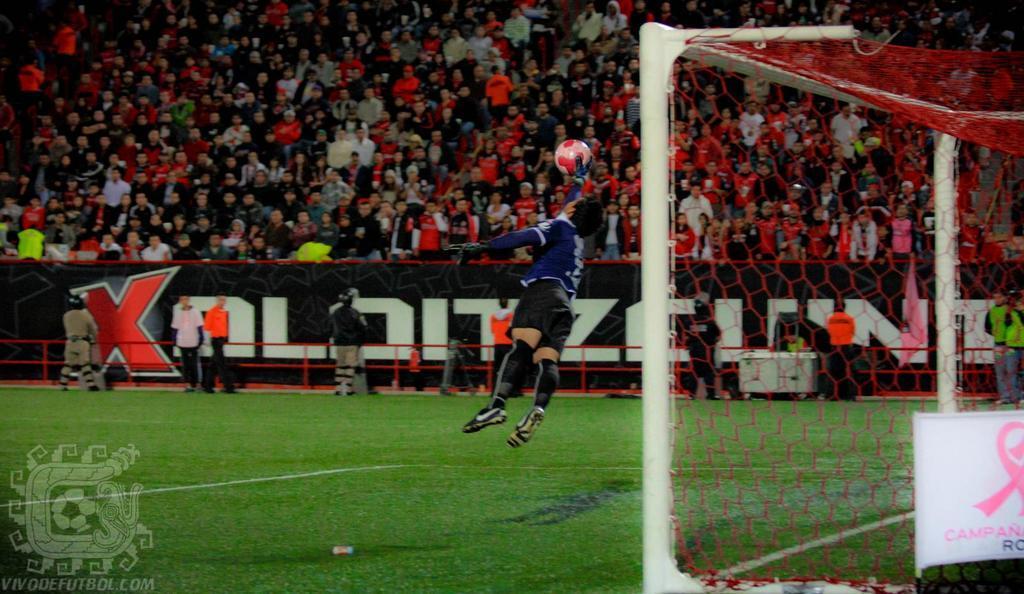Can you describe this image briefly? In this picture there are group of people standing behind the board and there is text on the board and there are group of people standing behind the railing and there is a person holding the ball and he is jumping. On the right side of the image there is a net and there is a board and there is text on the board. At the bottom there is grass. 